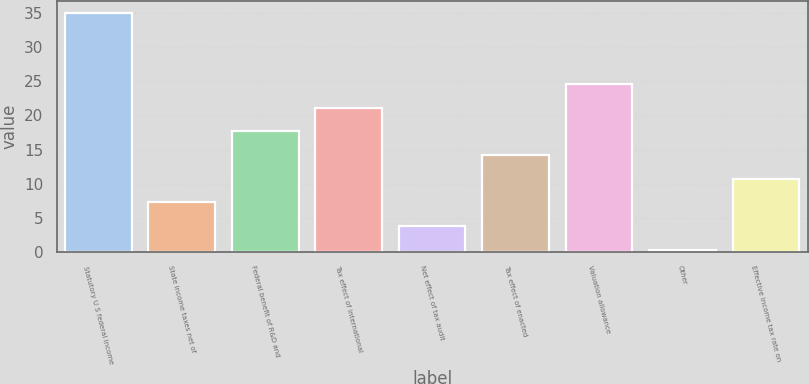Convert chart. <chart><loc_0><loc_0><loc_500><loc_500><bar_chart><fcel>Statutory U S federal income<fcel>State income taxes net of<fcel>Federal benefit of R&D and<fcel>Tax effect of international<fcel>Net effect of tax audit<fcel>Tax effect of enacted<fcel>Valuation allowance<fcel>Other<fcel>Effective income tax rate on<nl><fcel>35<fcel>7.24<fcel>17.65<fcel>21.12<fcel>3.77<fcel>14.18<fcel>24.59<fcel>0.3<fcel>10.71<nl></chart> 